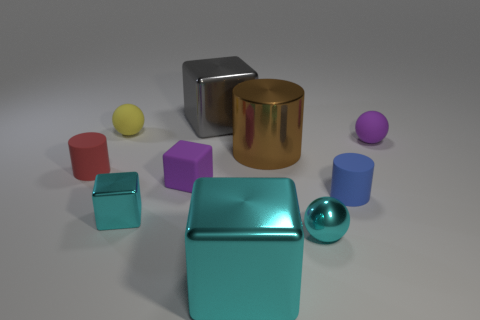Do the cyan thing left of the purple cube and the gray shiny thing have the same shape?
Offer a very short reply. Yes. There is a small cylinder that is on the right side of the tiny matte sphere that is left of the tiny purple sphere; what color is it?
Ensure brevity in your answer.  Blue. How many objects are the same color as the metal ball?
Ensure brevity in your answer.  2. There is a tiny metal cube; is it the same color as the ball that is in front of the small red matte object?
Provide a short and direct response. Yes. Is the number of small cyan objects less than the number of cubes?
Offer a very short reply. Yes. Is the number of shiny objects that are right of the tiny yellow matte object greater than the number of tiny cylinders that are on the left side of the blue cylinder?
Provide a succinct answer. Yes. Does the gray block have the same material as the cyan ball?
Ensure brevity in your answer.  Yes. What number of red rubber things are on the left side of the blue matte object on the right side of the red rubber cylinder?
Ensure brevity in your answer.  1. Do the big object in front of the tiny shiny block and the tiny metallic ball have the same color?
Ensure brevity in your answer.  Yes. How many objects are gray things or large blocks that are in front of the red cylinder?
Give a very brief answer. 2. 